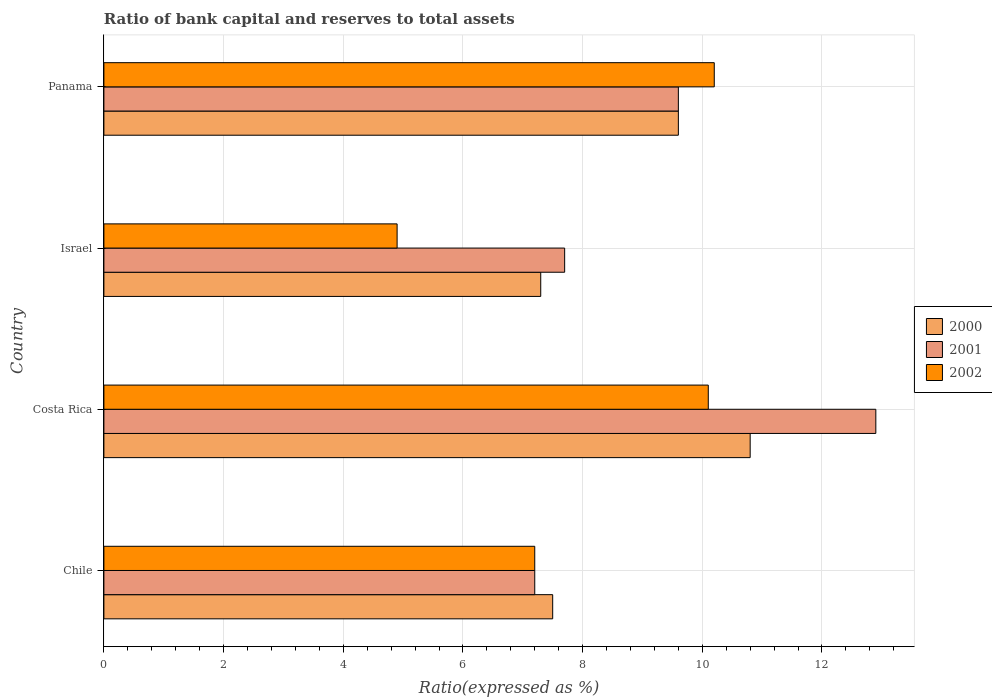How many groups of bars are there?
Your answer should be very brief. 4. Are the number of bars on each tick of the Y-axis equal?
Give a very brief answer. Yes. How many bars are there on the 2nd tick from the bottom?
Provide a succinct answer. 3. In how many cases, is the number of bars for a given country not equal to the number of legend labels?
Provide a succinct answer. 0. What is the ratio of bank capital and reserves to total assets in 2001 in Israel?
Give a very brief answer. 7.7. Across all countries, what is the maximum ratio of bank capital and reserves to total assets in 2001?
Your response must be concise. 12.9. In which country was the ratio of bank capital and reserves to total assets in 2001 minimum?
Provide a succinct answer. Chile. What is the total ratio of bank capital and reserves to total assets in 2002 in the graph?
Your answer should be compact. 32.4. What is the difference between the ratio of bank capital and reserves to total assets in 2001 in Israel and the ratio of bank capital and reserves to total assets in 2000 in Panama?
Offer a terse response. -1.9. What is the difference between the ratio of bank capital and reserves to total assets in 2001 and ratio of bank capital and reserves to total assets in 2002 in Costa Rica?
Offer a terse response. 2.8. What is the ratio of the ratio of bank capital and reserves to total assets in 2000 in Chile to that in Panama?
Your response must be concise. 0.78. Is the difference between the ratio of bank capital and reserves to total assets in 2001 in Chile and Israel greater than the difference between the ratio of bank capital and reserves to total assets in 2002 in Chile and Israel?
Your answer should be very brief. No. What is the difference between the highest and the second highest ratio of bank capital and reserves to total assets in 2000?
Keep it short and to the point. 1.2. What is the difference between the highest and the lowest ratio of bank capital and reserves to total assets in 2002?
Offer a terse response. 5.3. In how many countries, is the ratio of bank capital and reserves to total assets in 2001 greater than the average ratio of bank capital and reserves to total assets in 2001 taken over all countries?
Keep it short and to the point. 2. Is it the case that in every country, the sum of the ratio of bank capital and reserves to total assets in 2001 and ratio of bank capital and reserves to total assets in 2002 is greater than the ratio of bank capital and reserves to total assets in 2000?
Offer a terse response. Yes. Are all the bars in the graph horizontal?
Provide a succinct answer. Yes. What is the difference between two consecutive major ticks on the X-axis?
Offer a very short reply. 2. Does the graph contain any zero values?
Make the answer very short. No. Where does the legend appear in the graph?
Provide a succinct answer. Center right. How many legend labels are there?
Offer a very short reply. 3. How are the legend labels stacked?
Offer a terse response. Vertical. What is the title of the graph?
Your response must be concise. Ratio of bank capital and reserves to total assets. Does "1961" appear as one of the legend labels in the graph?
Your response must be concise. No. What is the label or title of the X-axis?
Offer a very short reply. Ratio(expressed as %). What is the Ratio(expressed as %) of 2000 in Chile?
Ensure brevity in your answer.  7.5. What is the Ratio(expressed as %) of 2001 in Chile?
Offer a terse response. 7.2. What is the Ratio(expressed as %) in 2002 in Chile?
Ensure brevity in your answer.  7.2. What is the Ratio(expressed as %) of 2000 in Costa Rica?
Provide a short and direct response. 10.8. What is the Ratio(expressed as %) of 2001 in Costa Rica?
Your response must be concise. 12.9. What is the Ratio(expressed as %) of 2002 in Israel?
Ensure brevity in your answer.  4.9. What is the Ratio(expressed as %) of 2002 in Panama?
Offer a terse response. 10.2. Across all countries, what is the maximum Ratio(expressed as %) of 2000?
Make the answer very short. 10.8. Across all countries, what is the minimum Ratio(expressed as %) in 2001?
Ensure brevity in your answer.  7.2. Across all countries, what is the minimum Ratio(expressed as %) of 2002?
Your response must be concise. 4.9. What is the total Ratio(expressed as %) of 2000 in the graph?
Make the answer very short. 35.2. What is the total Ratio(expressed as %) in 2001 in the graph?
Provide a succinct answer. 37.4. What is the total Ratio(expressed as %) of 2002 in the graph?
Give a very brief answer. 32.4. What is the difference between the Ratio(expressed as %) in 2000 in Chile and that in Costa Rica?
Offer a very short reply. -3.3. What is the difference between the Ratio(expressed as %) of 2001 in Chile and that in Costa Rica?
Provide a succinct answer. -5.7. What is the difference between the Ratio(expressed as %) of 2002 in Chile and that in Panama?
Your answer should be very brief. -3. What is the difference between the Ratio(expressed as %) in 2000 in Costa Rica and that in Israel?
Your answer should be compact. 3.5. What is the difference between the Ratio(expressed as %) of 2001 in Costa Rica and that in Israel?
Make the answer very short. 5.2. What is the difference between the Ratio(expressed as %) in 2000 in Costa Rica and that in Panama?
Your answer should be very brief. 1.2. What is the difference between the Ratio(expressed as %) in 2000 in Chile and the Ratio(expressed as %) in 2001 in Costa Rica?
Your answer should be very brief. -5.4. What is the difference between the Ratio(expressed as %) of 2000 in Chile and the Ratio(expressed as %) of 2002 in Costa Rica?
Your answer should be compact. -2.6. What is the difference between the Ratio(expressed as %) in 2000 in Chile and the Ratio(expressed as %) in 2002 in Israel?
Make the answer very short. 2.6. What is the difference between the Ratio(expressed as %) in 2001 in Chile and the Ratio(expressed as %) in 2002 in Israel?
Offer a terse response. 2.3. What is the difference between the Ratio(expressed as %) of 2001 in Chile and the Ratio(expressed as %) of 2002 in Panama?
Make the answer very short. -3. What is the difference between the Ratio(expressed as %) of 2000 in Costa Rica and the Ratio(expressed as %) of 2001 in Panama?
Keep it short and to the point. 1.2. What is the difference between the Ratio(expressed as %) in 2000 in Costa Rica and the Ratio(expressed as %) in 2002 in Panama?
Give a very brief answer. 0.6. What is the difference between the Ratio(expressed as %) of 2001 in Costa Rica and the Ratio(expressed as %) of 2002 in Panama?
Give a very brief answer. 2.7. What is the difference between the Ratio(expressed as %) in 2000 in Israel and the Ratio(expressed as %) in 2001 in Panama?
Keep it short and to the point. -2.3. What is the difference between the Ratio(expressed as %) in 2001 in Israel and the Ratio(expressed as %) in 2002 in Panama?
Your answer should be compact. -2.5. What is the average Ratio(expressed as %) of 2000 per country?
Offer a terse response. 8.8. What is the average Ratio(expressed as %) of 2001 per country?
Offer a very short reply. 9.35. What is the difference between the Ratio(expressed as %) in 2000 and Ratio(expressed as %) in 2002 in Chile?
Ensure brevity in your answer.  0.3. What is the difference between the Ratio(expressed as %) of 2000 and Ratio(expressed as %) of 2001 in Costa Rica?
Offer a terse response. -2.1. What is the difference between the Ratio(expressed as %) in 2001 and Ratio(expressed as %) in 2002 in Costa Rica?
Make the answer very short. 2.8. What is the difference between the Ratio(expressed as %) in 2000 and Ratio(expressed as %) in 2001 in Israel?
Ensure brevity in your answer.  -0.4. What is the difference between the Ratio(expressed as %) of 2000 and Ratio(expressed as %) of 2002 in Israel?
Keep it short and to the point. 2.4. What is the difference between the Ratio(expressed as %) of 2001 and Ratio(expressed as %) of 2002 in Israel?
Offer a terse response. 2.8. What is the difference between the Ratio(expressed as %) in 2000 and Ratio(expressed as %) in 2001 in Panama?
Your answer should be very brief. 0. What is the ratio of the Ratio(expressed as %) of 2000 in Chile to that in Costa Rica?
Give a very brief answer. 0.69. What is the ratio of the Ratio(expressed as %) of 2001 in Chile to that in Costa Rica?
Provide a short and direct response. 0.56. What is the ratio of the Ratio(expressed as %) in 2002 in Chile to that in Costa Rica?
Offer a terse response. 0.71. What is the ratio of the Ratio(expressed as %) of 2000 in Chile to that in Israel?
Provide a succinct answer. 1.03. What is the ratio of the Ratio(expressed as %) of 2001 in Chile to that in Israel?
Ensure brevity in your answer.  0.94. What is the ratio of the Ratio(expressed as %) in 2002 in Chile to that in Israel?
Make the answer very short. 1.47. What is the ratio of the Ratio(expressed as %) of 2000 in Chile to that in Panama?
Keep it short and to the point. 0.78. What is the ratio of the Ratio(expressed as %) in 2001 in Chile to that in Panama?
Your answer should be compact. 0.75. What is the ratio of the Ratio(expressed as %) in 2002 in Chile to that in Panama?
Ensure brevity in your answer.  0.71. What is the ratio of the Ratio(expressed as %) of 2000 in Costa Rica to that in Israel?
Offer a very short reply. 1.48. What is the ratio of the Ratio(expressed as %) in 2001 in Costa Rica to that in Israel?
Your answer should be very brief. 1.68. What is the ratio of the Ratio(expressed as %) in 2002 in Costa Rica to that in Israel?
Your answer should be very brief. 2.06. What is the ratio of the Ratio(expressed as %) in 2001 in Costa Rica to that in Panama?
Provide a succinct answer. 1.34. What is the ratio of the Ratio(expressed as %) in 2002 in Costa Rica to that in Panama?
Ensure brevity in your answer.  0.99. What is the ratio of the Ratio(expressed as %) of 2000 in Israel to that in Panama?
Provide a succinct answer. 0.76. What is the ratio of the Ratio(expressed as %) of 2001 in Israel to that in Panama?
Offer a terse response. 0.8. What is the ratio of the Ratio(expressed as %) in 2002 in Israel to that in Panama?
Give a very brief answer. 0.48. What is the difference between the highest and the second highest Ratio(expressed as %) in 2000?
Offer a terse response. 1.2. What is the difference between the highest and the second highest Ratio(expressed as %) of 2002?
Your answer should be compact. 0.1. What is the difference between the highest and the lowest Ratio(expressed as %) in 2002?
Offer a terse response. 5.3. 